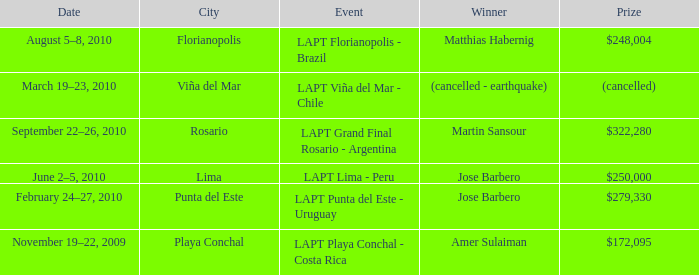Who is the victor in the city of lima? Jose Barbero. 